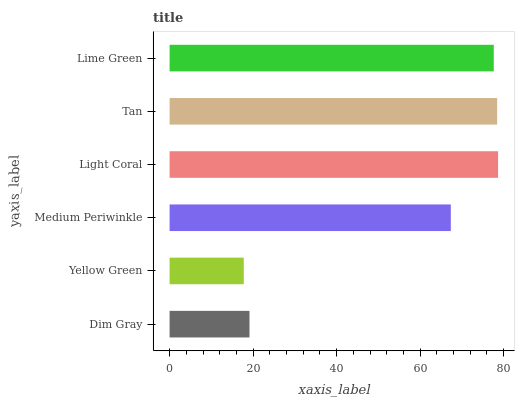Is Yellow Green the minimum?
Answer yes or no. Yes. Is Light Coral the maximum?
Answer yes or no. Yes. Is Medium Periwinkle the minimum?
Answer yes or no. No. Is Medium Periwinkle the maximum?
Answer yes or no. No. Is Medium Periwinkle greater than Yellow Green?
Answer yes or no. Yes. Is Yellow Green less than Medium Periwinkle?
Answer yes or no. Yes. Is Yellow Green greater than Medium Periwinkle?
Answer yes or no. No. Is Medium Periwinkle less than Yellow Green?
Answer yes or no. No. Is Lime Green the high median?
Answer yes or no. Yes. Is Medium Periwinkle the low median?
Answer yes or no. Yes. Is Yellow Green the high median?
Answer yes or no. No. Is Yellow Green the low median?
Answer yes or no. No. 